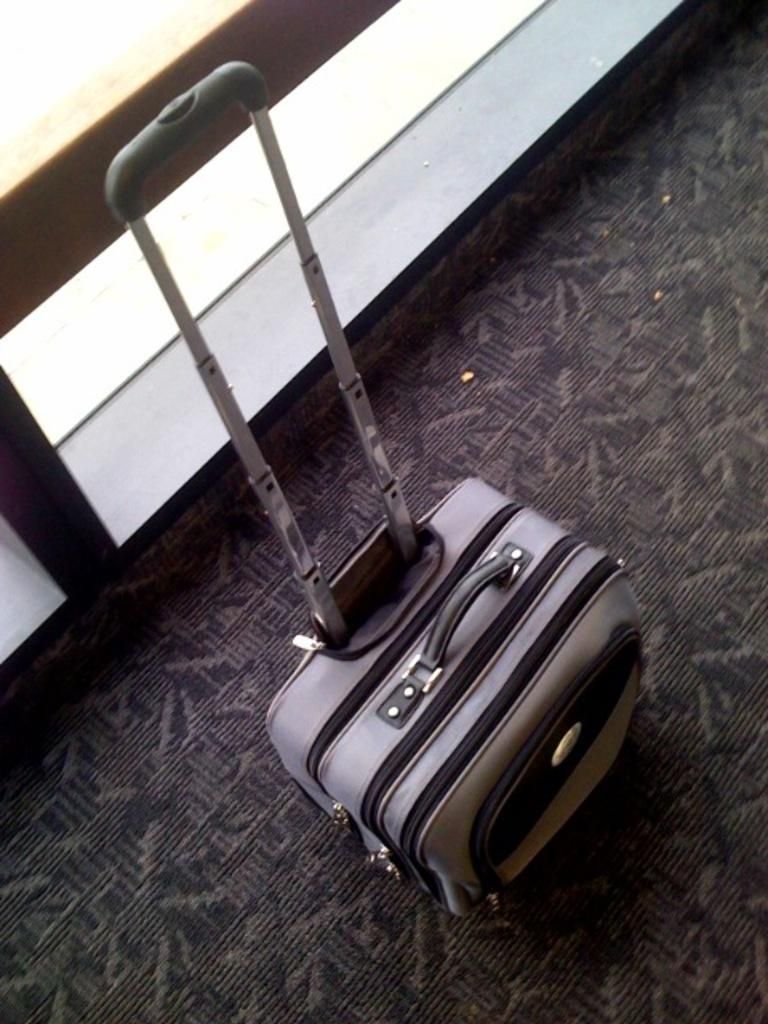What type of luggage is visible in the image? There is a trolley luggage bag in the image. What is the position of the handle on the luggage bag? The handle of the luggage bag is fully pulled. How many nails can be seen in the image? There are no nails visible in the image. What day of the week is depicted in the image? The image does not depict a specific day of the week. 